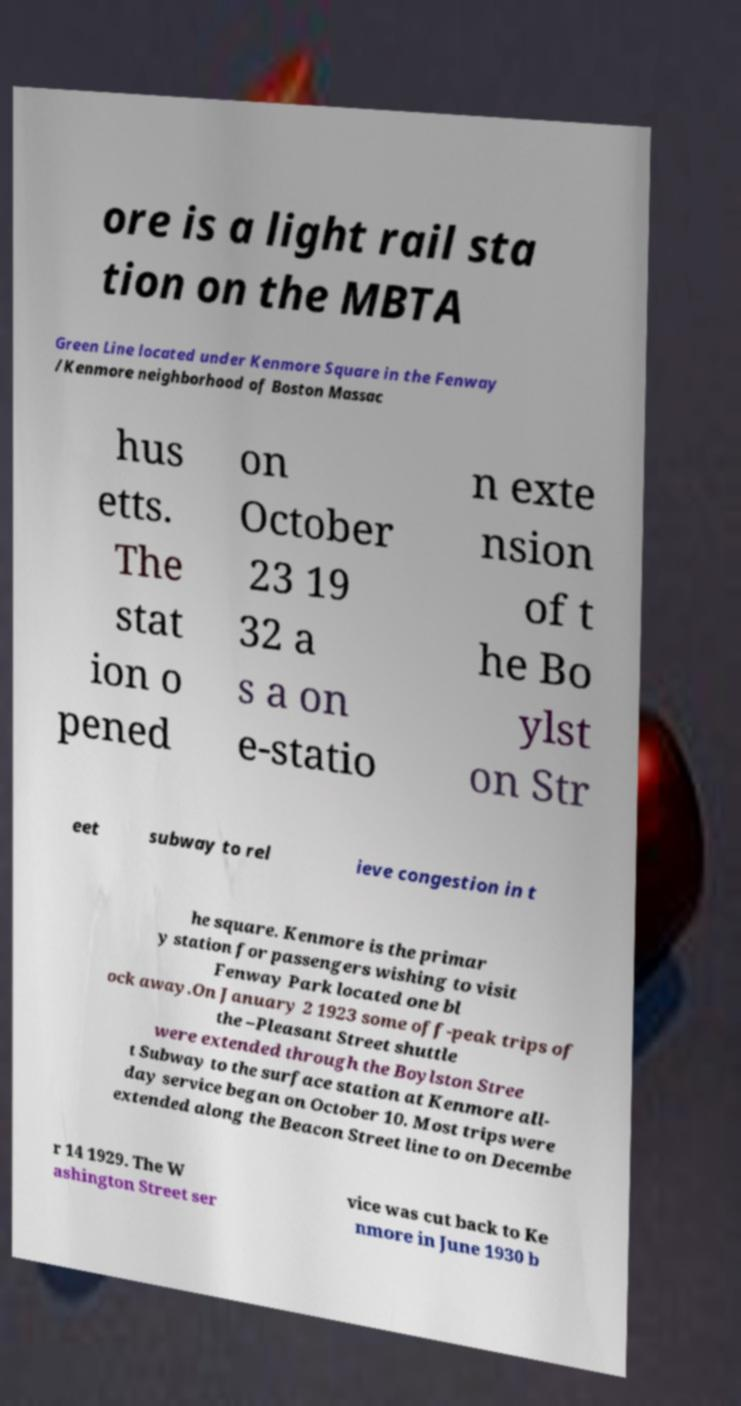Please read and relay the text visible in this image. What does it say? ore is a light rail sta tion on the MBTA Green Line located under Kenmore Square in the Fenway /Kenmore neighborhood of Boston Massac hus etts. The stat ion o pened on October 23 19 32 a s a on e-statio n exte nsion of t he Bo ylst on Str eet subway to rel ieve congestion in t he square. Kenmore is the primar y station for passengers wishing to visit Fenway Park located one bl ock away.On January 2 1923 some off-peak trips of the –Pleasant Street shuttle were extended through the Boylston Stree t Subway to the surface station at Kenmore all- day service began on October 10. Most trips were extended along the Beacon Street line to on Decembe r 14 1929. The W ashington Street ser vice was cut back to Ke nmore in June 1930 b 